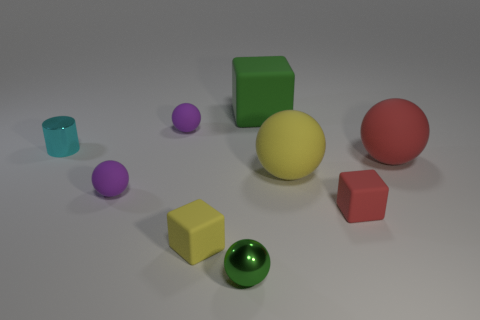Subtract all red rubber blocks. How many blocks are left? 2 Subtract all yellow spheres. How many spheres are left? 4 Subtract all cylinders. How many objects are left? 8 Add 8 metal things. How many metal things are left? 10 Add 7 big red balls. How many big red balls exist? 8 Subtract 0 red cylinders. How many objects are left? 9 Subtract 3 spheres. How many spheres are left? 2 Subtract all blue blocks. Subtract all yellow cylinders. How many blocks are left? 3 Subtract all blue cylinders. How many purple spheres are left? 2 Subtract all green objects. Subtract all small red matte objects. How many objects are left? 6 